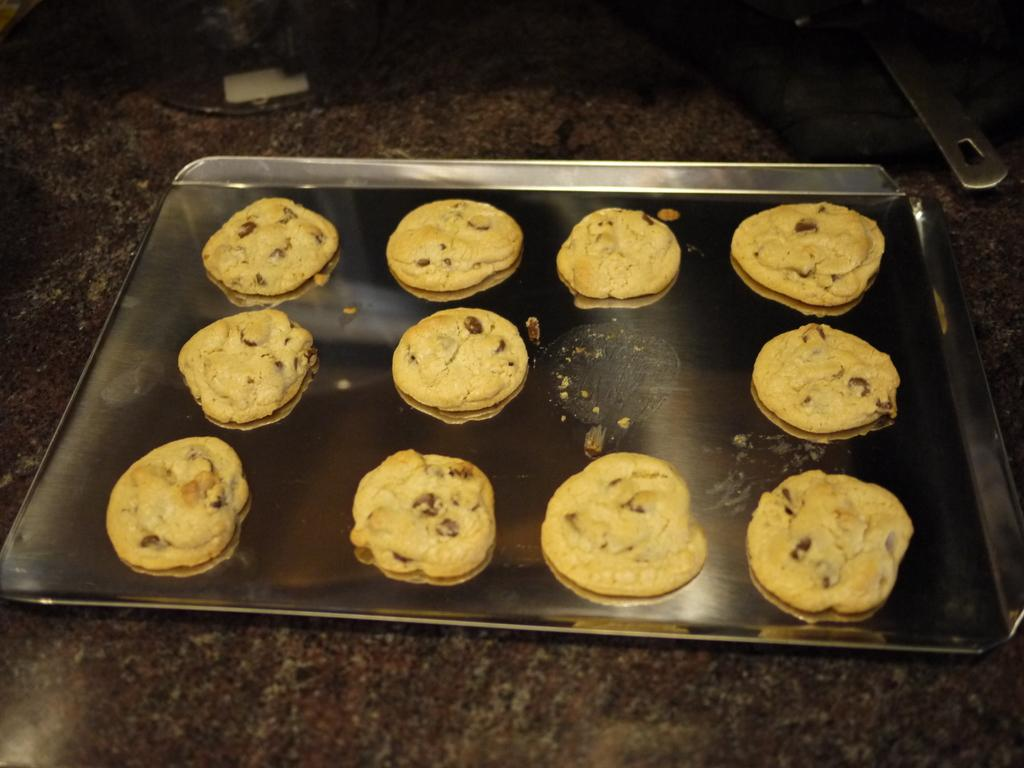What is on the tray that is visible in the image? There is a tray of choco chip cookies in the image. Where is the tray placed in the image? The tray is placed on a surface in the image. What utensil can be seen in the image? There is a spoon visible in the image. What type of weather can be seen through the door in the image? There is no door present in the image, so it is not possible to determine the weather outside. 